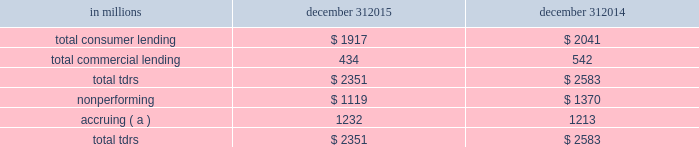Troubled debt restructurings ( tdrs ) a tdr is a loan whose terms have been restructured in a manner that grants a concession to a borrower experiencing financial difficulty .
Tdrs result from our loss mitigation activities , and include rate reductions , principal forgiveness , postponement/reduction of scheduled amortization , and extensions , which are intended to minimize economic loss and to avoid foreclosure or repossession of collateral .
Additionally , tdrs also result from borrowers that have been discharged from personal liability through chapter 7 bankruptcy and have not formally reaffirmed their loan obligations to pnc .
In those situations where principal is forgiven , the amount of such principal forgiveness is immediately charged off .
Some tdrs may not ultimately result in the full collection of principal and interest , as restructured , and result in potential incremental losses .
These potential incremental losses have been factored into our overall alll estimate .
The level of any subsequent defaults will likely be affected by future economic conditions .
Once a loan becomes a tdr , it will continue to be reported as a tdr until it is ultimately repaid in full , the collateral is foreclosed upon , or it is fully charged off .
We held specific reserves in the alll of $ .3 billion and $ .4 billion at december 31 , 2015 and december 31 , 2014 , respectively , for the total tdr portfolio .
Table 61 : summary of troubled debt restructurings in millions december 31 december 31 .
( a ) accruing loans include consumer credit card loans and loans that have demonstrated a period of at least six months of performance under the restructured terms and are excluded from nonperforming loans .
Loans where borrowers have been discharged from personal liability through chapter 7 bankruptcy and have not formally reaffirmed their loan obligations to pnc and loans to borrowers not currently obligated to make both principal and interest payments under the restructured terms are not returned to accrual status .
Table 62 quantifies the number of loans that were classified as tdrs as well as the change in the recorded investments as a result of the tdr classification during the years 2015 , 2014 and 2013 respectively .
Additionally , the table provides information about the types of tdr concessions .
The principal forgiveness tdr category includes principal forgiveness and accrued interest forgiveness .
These types of tdrs result in a write down of the recorded investment and a charge-off if such action has not already taken place .
The rate reduction tdr category includes reduced interest rate and interest deferral .
The tdrs within this category result in reductions to future interest income .
The other tdr category primarily includes consumer borrowers that have been discharged from personal liability through chapter 7 bankruptcy and have not formally reaffirmed their loan obligations to pnc , as well as postponement/reduction of scheduled amortization and contractual extensions for both consumer and commercial borrowers .
In some cases , there have been multiple concessions granted on one loan .
This is most common within the commercial loan portfolio .
When there have been multiple concessions granted in the commercial loan portfolio , the principal forgiveness concession was prioritized for purposes of determining the inclusion in table 62 .
For example , if there is principal forgiveness in conjunction with lower interest rate and postponement of amortization , the type of concession will be reported as principal forgiveness .
Second in priority would be rate reduction .
For example , if there is an interest rate reduction in conjunction with postponement of amortization , the type of concession will be reported as a rate reduction .
In the event that multiple concessions are granted on a consumer loan , concessions resulting from discharge from personal liability through chapter 7 bankruptcy without formal affirmation of the loan obligations to pnc would be prioritized and included in the other type of concession in the table below .
After that , consumer loan concessions would follow the previously discussed priority of concessions for the commercial loan portfolio .
136 the pnc financial services group , inc .
2013 form 10-k .
What was the change in specific reserves in alll between december 31 , 2015 and december 31 , 2014 in billions? 
Computations: (.3 - .4)
Answer: -0.1. 